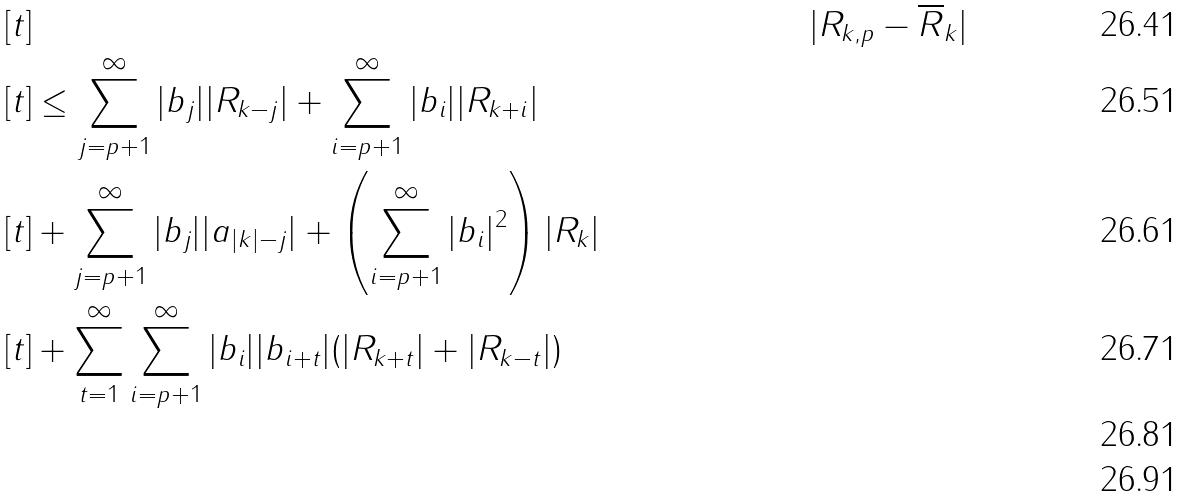Convert formula to latex. <formula><loc_0><loc_0><loc_500><loc_500>& \, [ t ] & & | R _ { k , p } - \overline { R } _ { k } | \\ & \, [ t ] \leq \sum _ { j = p + 1 } ^ { \infty } | b _ { j } | | R _ { k - j } | + \sum _ { i = p + 1 } ^ { \infty } | b _ { i } | | R _ { k + i } | \\ & \, [ t ] + \sum _ { j = p + 1 } ^ { \infty } | b _ { j } | | a _ { | k | - j } | + \left ( \sum _ { i = p + 1 } ^ { \infty } | b _ { i } | ^ { 2 } \right ) | R _ { k } | \\ & \, [ t ] + \sum _ { t = 1 } ^ { \infty } \sum _ { i = p + 1 } ^ { \infty } | b _ { i } | | b _ { i + t } | ( | R _ { k + t } | + | R _ { k - t } | ) \\ \\</formula> 